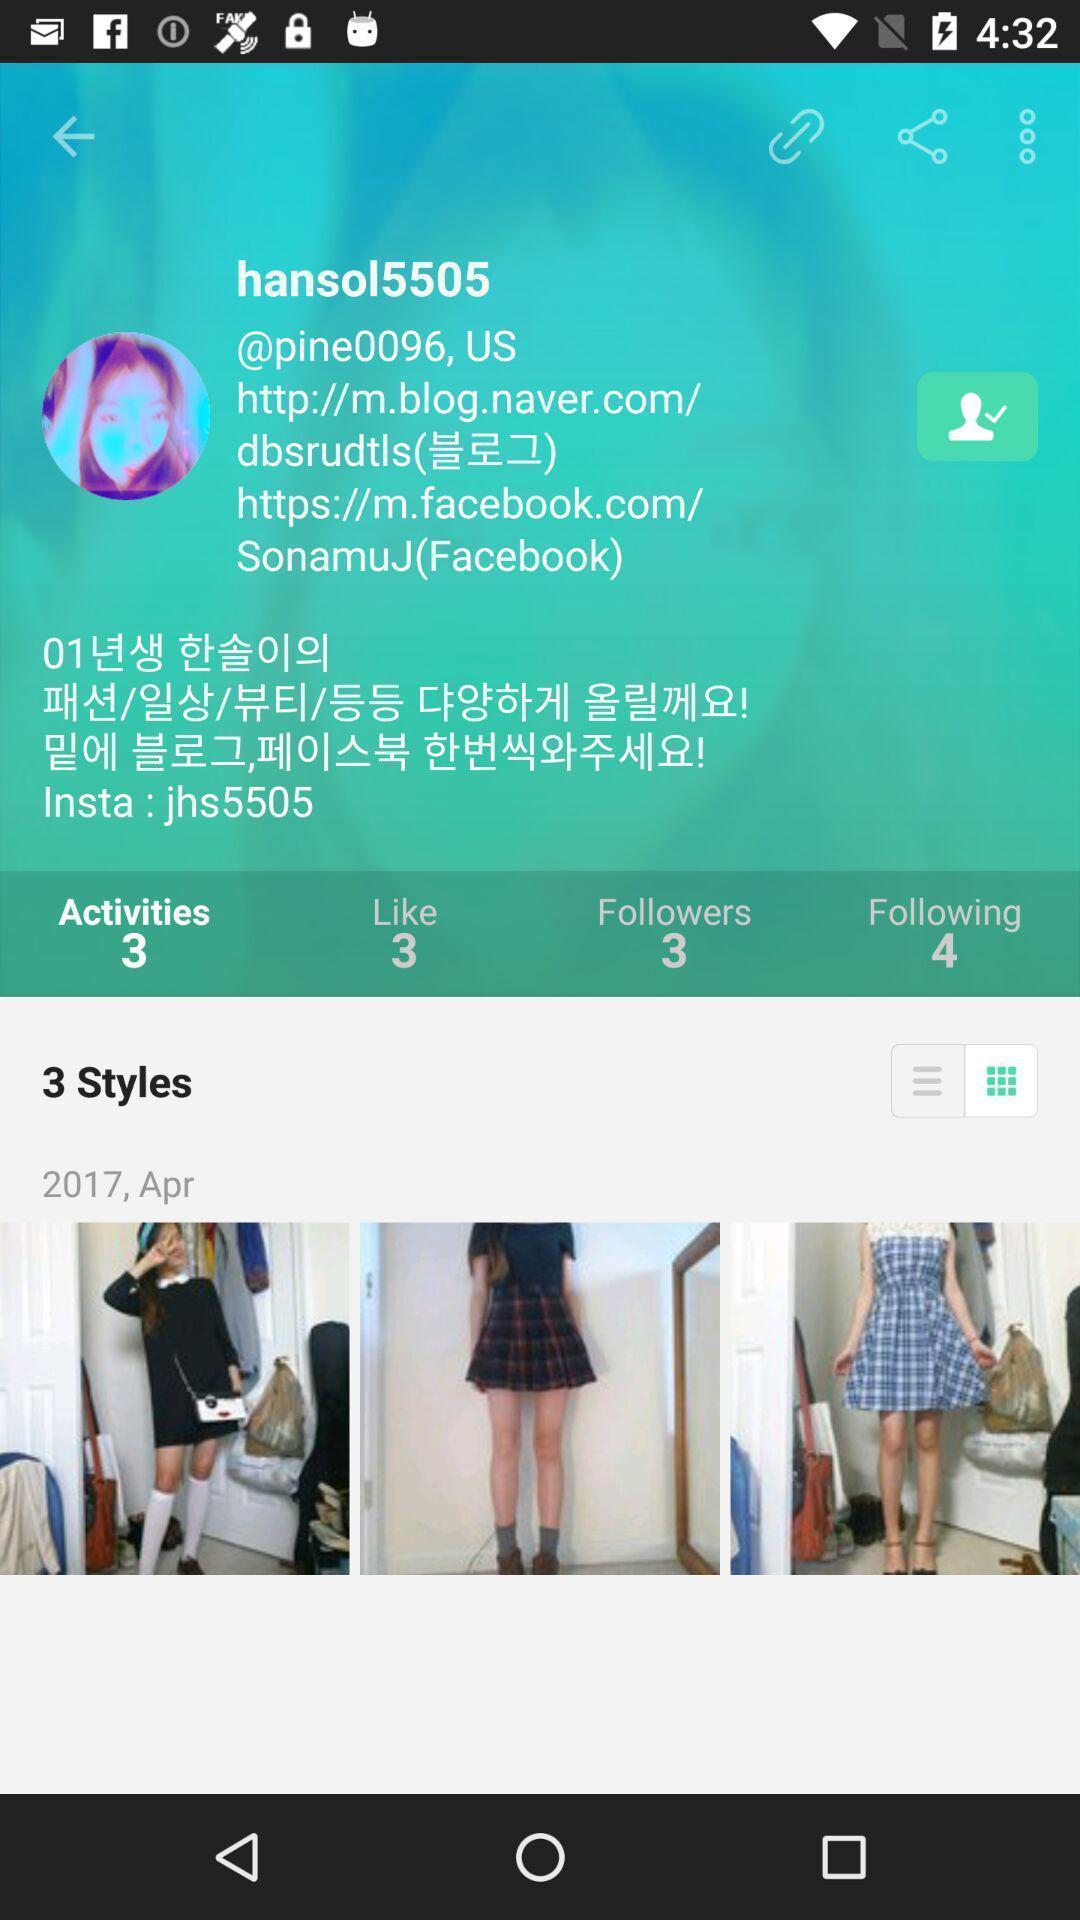Give me a narrative description of this picture. Screen displaying the activities page. 